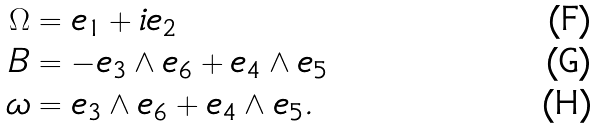Convert formula to latex. <formula><loc_0><loc_0><loc_500><loc_500>\Omega & = e _ { 1 } + i e _ { 2 } \\ B & = - e _ { 3 } \wedge e _ { 6 } + e _ { 4 } \wedge e _ { 5 } \\ \omega & = e _ { 3 } \wedge e _ { 6 } + e _ { 4 } \wedge e _ { 5 } .</formula> 